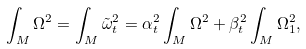<formula> <loc_0><loc_0><loc_500><loc_500>\int _ { M } \Omega ^ { 2 } = \int _ { M } \tilde { \omega } _ { t } ^ { 2 } = \alpha _ { t } ^ { 2 } \int _ { M } \Omega ^ { 2 } + \beta _ { t } ^ { 2 } \int _ { M } \Omega _ { 1 } ^ { 2 } ,</formula> 